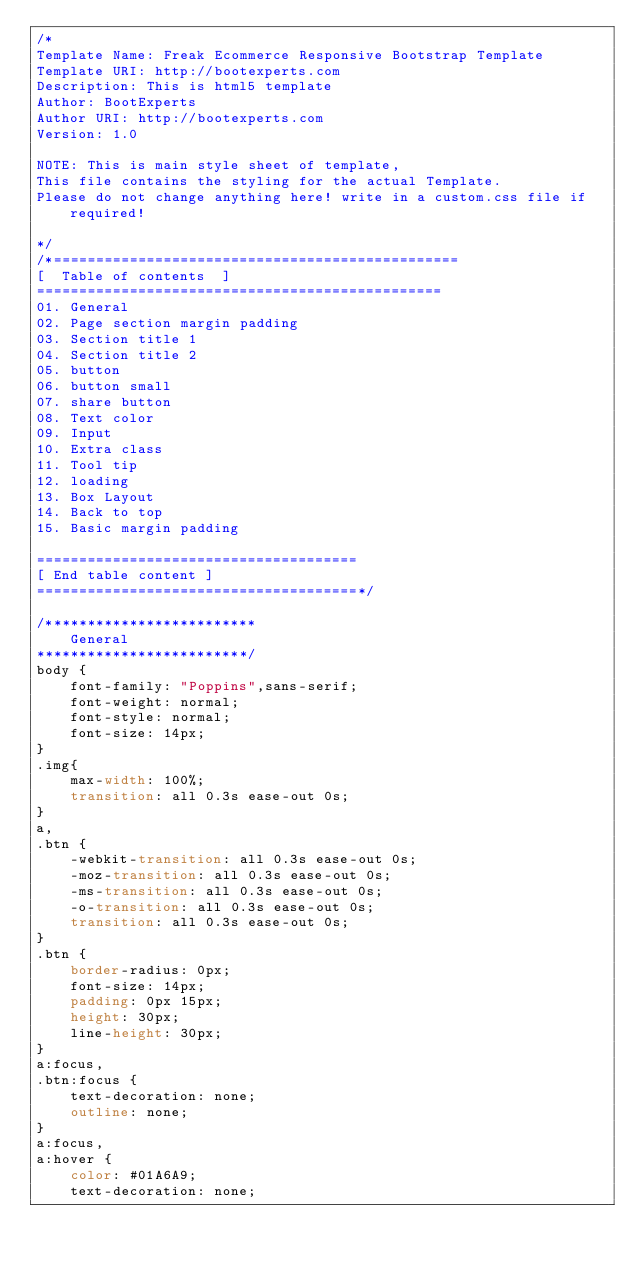<code> <loc_0><loc_0><loc_500><loc_500><_CSS_>/*
Template Name: Freak Ecommerce Responsive Bootstrap Template
Template URI: http://bootexperts.com
Description: This is html5 template
Author: BootExperts
Author URI: http://bootexperts.com
Version: 1.0

NOTE: This is main style sheet of template, 
This file contains the styling for the actual Template. 
Please do not change anything here! write in a custom.css file if required!

*/
/*================================================
[  Table of contents  ]
================================================
01. General
02. Page section margin padding 
03. Section title 1
04. Section title 2
05. button
06. button small
07. share button
08. Text color
09. Input
10. Extra class
11. Tool tip
12. loading
13. Box Layout
14. Back to top
15. Basic margin padding
 
======================================
[ End table content ]
======================================*/

/*************************
    General
*************************/
body {
    font-family: "Poppins",sans-serif;
    font-weight: normal;
    font-style: normal;
    font-size: 14px;
}
.img{
    max-width: 100%;
    transition: all 0.3s ease-out 0s;
}
a,
.btn {
    -webkit-transition: all 0.3s ease-out 0s;
    -moz-transition: all 0.3s ease-out 0s;
    -ms-transition: all 0.3s ease-out 0s;
    -o-transition: all 0.3s ease-out 0s;
    transition: all 0.3s ease-out 0s;
}
.btn {
    border-radius: 0px;
    font-size: 14px;
    padding: 0px 15px;
    height: 30px;
    line-height: 30px;
}
a:focus,
.btn:focus {
    text-decoration: none;
    outline: none;
}
a:focus,
a:hover {
    color: #01A6A9;
    text-decoration: none;</code> 